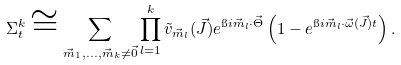<formula> <loc_0><loc_0><loc_500><loc_500>\Sigma _ { t } ^ { k } \cong \sum _ { \vec { m } _ { 1 } , \dots , \vec { m } _ { k } \neq \vec { 0 } } \prod _ { l = 1 } ^ { k } \tilde { v } _ { \vec { m } _ { l } } ( \vec { J } ) e ^ { \i i \vec { m } _ { l } \cdot \vec { \Theta } } \left ( 1 - e ^ { \i i \vec { m } _ { l } \cdot \vec { \omega } ( \vec { J } ) t } \right ) .</formula> 